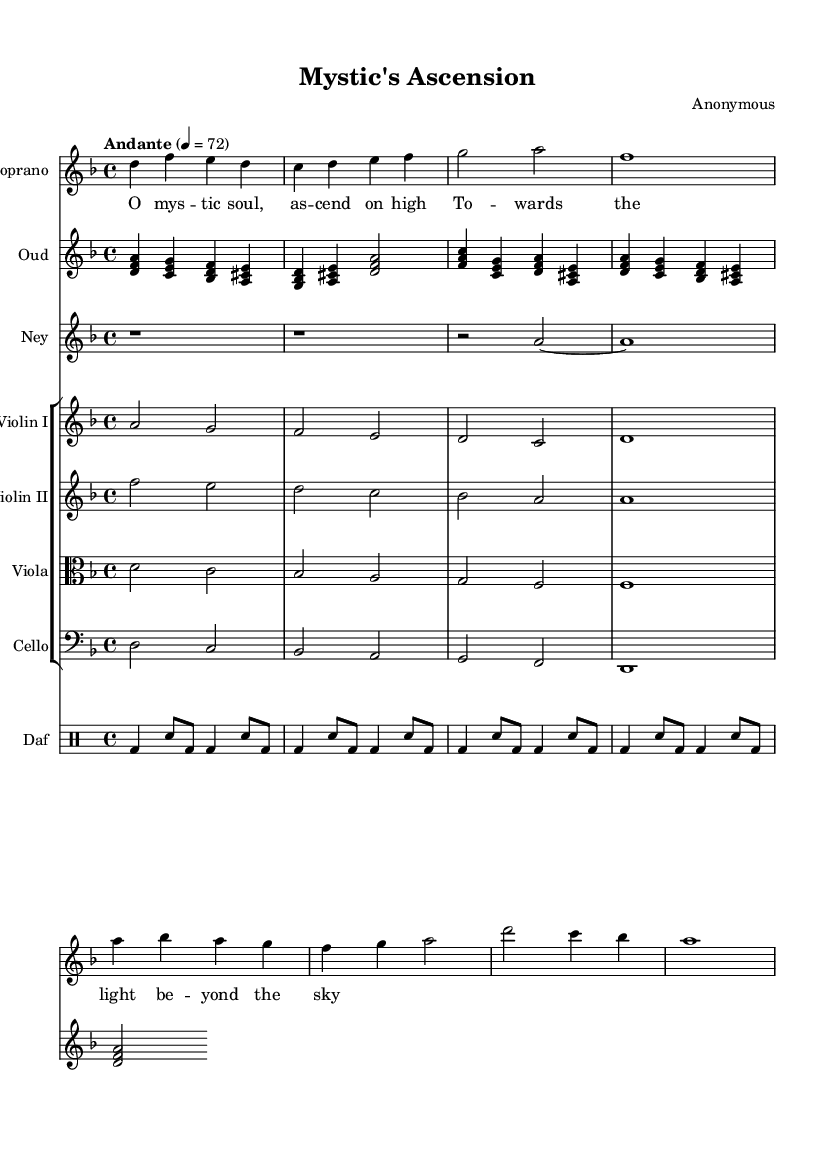What is the key signature of this music? The key signature is D minor, which contains one flat (B flat) indicated at the beginning of the staff.
Answer: D minor What is the time signature of the piece? The time signature is 4/4, which indicates four beats per measure, as shown at the beginning of the music.
Answer: 4/4 What is the tempo indication for this piece? The tempo is marked as "Andante," which suggests a moderate pace, specifically noted as 72 beats per minute.
Answer: Andante How many instruments are featured in the score? The score includes a soprano, oud, ney, two violins, a viola, a cello, and a daf, totaling eight instruments represented in separate staffs.
Answer: Eight What is the dynamic marking for the soprano part? There are no specific dynamic markings indicated for the soprano part in the provided code, implying either a default dynamic level or that dynamics are left to the performer's discretion.
Answer: None Which Sufi theme is suggested by the lyrics of the soprano verse? The lyrics speak of ascension and transcendence, typical themes in Sufi mysticism reflecting the journey of the soul toward divine enlightenment.
Answer: Ascension 